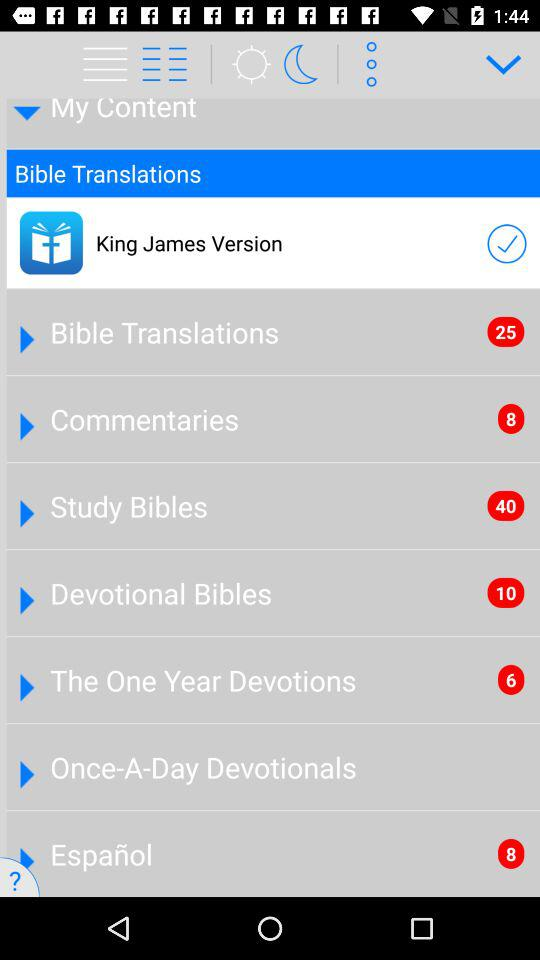How many more items are in the Devotional Bibles section than in the The One Year Devotions section?
Answer the question using a single word or phrase. 4 